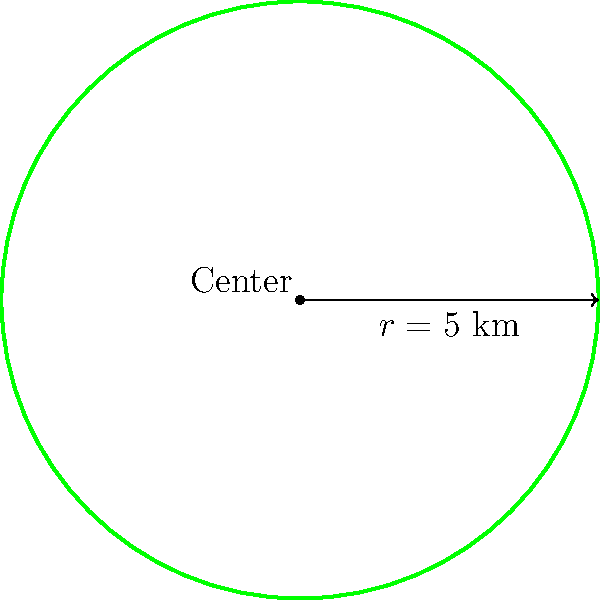You've discovered a circular hiking trail in a pristine natural reserve. The trail has a radius of 5 km from its center point. What is the total distance you'll cover if you complete one full loop around this circular trail? To find the total distance of the circular hiking trail, we need to calculate its perimeter. The perimeter of a circle is given by the formula $C = 2\pi r$, where $C$ is the circumference (perimeter) and $r$ is the radius.

Step 1: Identify the given information
Radius ($r$) = 5 km

Step 2: Apply the formula for the circumference of a circle
$C = 2\pi r$

Step 3: Substitute the value of $r$
$C = 2\pi (5)$

Step 4: Simplify
$C = 10\pi$ km

Step 5: Calculate the final value (rounded to two decimal places)
$C \approx 31.42$ km

Therefore, the total distance you'll cover in one full loop around the circular trail is approximately 31.42 km.
Answer: $31.42$ km 